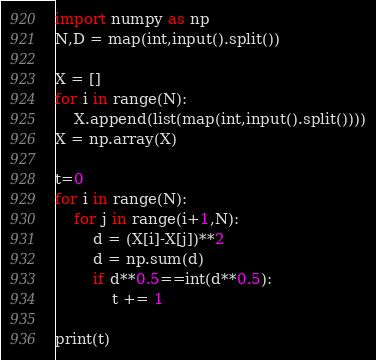<code> <loc_0><loc_0><loc_500><loc_500><_Python_>import numpy as np
N,D = map(int,input().split())

X = []
for i in range(N):
    X.append(list(map(int,input().split())))
X = np.array(X)

t=0
for i in range(N):
    for j in range(i+1,N):
        d = (X[i]-X[j])**2
        d = np.sum(d)
        if d**0.5==int(d**0.5):
            t += 1

print(t)</code> 